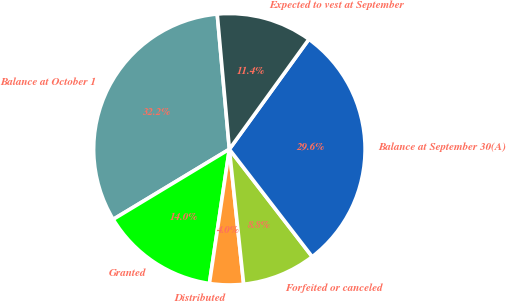Convert chart. <chart><loc_0><loc_0><loc_500><loc_500><pie_chart><fcel>Balance at October 1<fcel>Granted<fcel>Distributed<fcel>Forfeited or canceled<fcel>Balance at September 30(A)<fcel>Expected to vest at September<nl><fcel>32.22%<fcel>14.01%<fcel>4.03%<fcel>8.77%<fcel>29.59%<fcel>11.39%<nl></chart> 